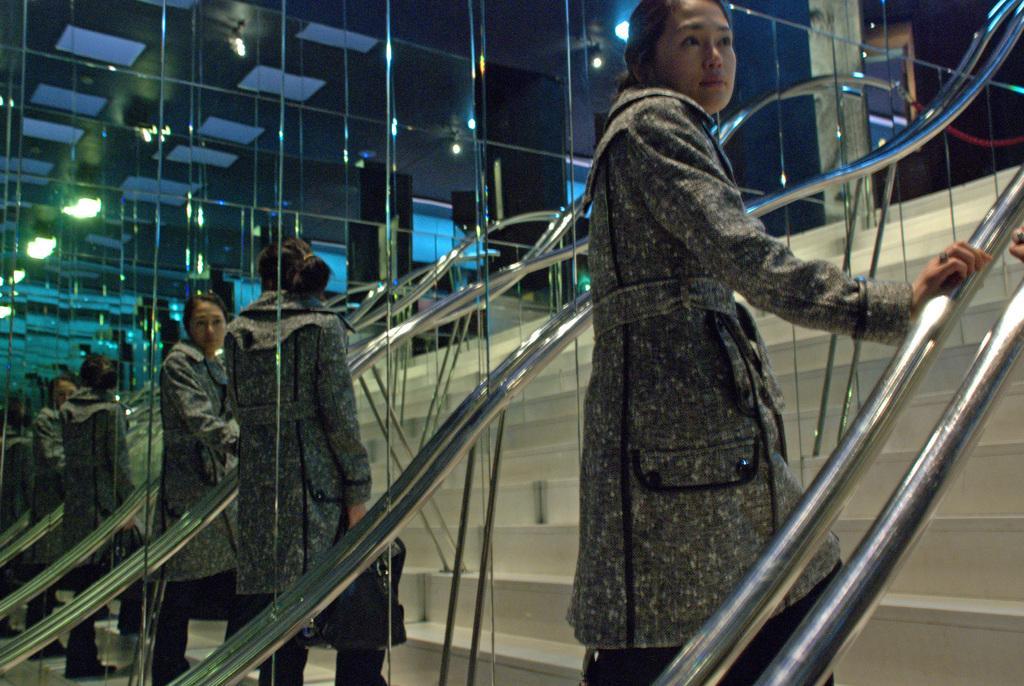Please provide a concise description of this image. In this image we can see a woman standing on the stairs. We can also see the railing. In the background we can see the glass and through the glass we can see the reflections of a woman on the stairs. We can also see the ceiling and also the lights. 